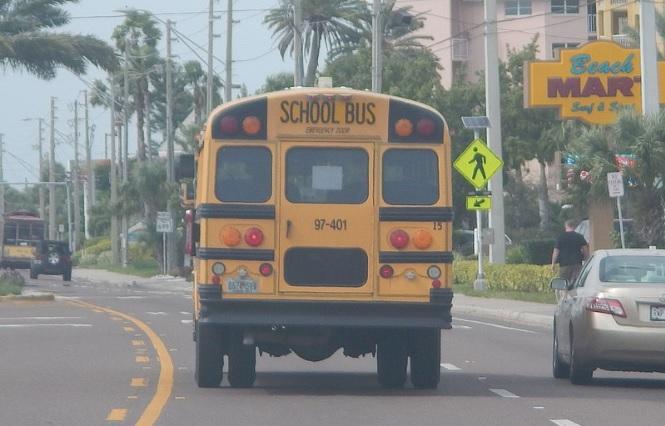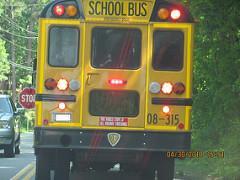The first image is the image on the left, the second image is the image on the right. Assess this claim about the two images: "At least one bus is driving next to other cars.". Correct or not? Answer yes or no. Yes. The first image is the image on the left, the second image is the image on the right. Assess this claim about the two images: "One image shows at least five school buses parked next to each other.". Correct or not? Answer yes or no. No. 